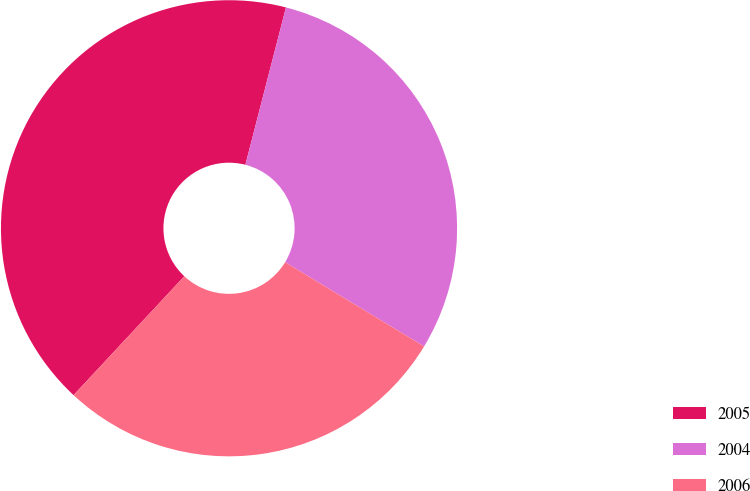Convert chart to OTSL. <chart><loc_0><loc_0><loc_500><loc_500><pie_chart><fcel>2005<fcel>2004<fcel>2006<nl><fcel>42.08%<fcel>29.65%<fcel>28.27%<nl></chart> 